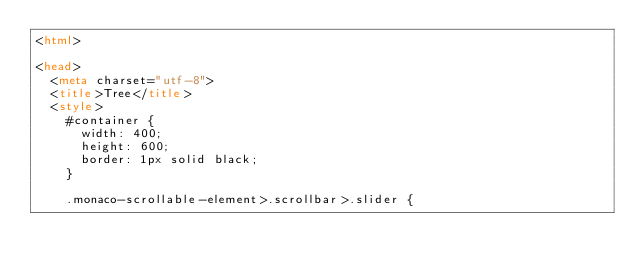<code> <loc_0><loc_0><loc_500><loc_500><_HTML_><html>

<head>
	<meta charset="utf-8">
	<title>Tree</title>
	<style>
		#container {
			width: 400;
			height: 600;
			border: 1px solid black;
		}

		.monaco-scrollable-element>.scrollbar>.slider {</code> 